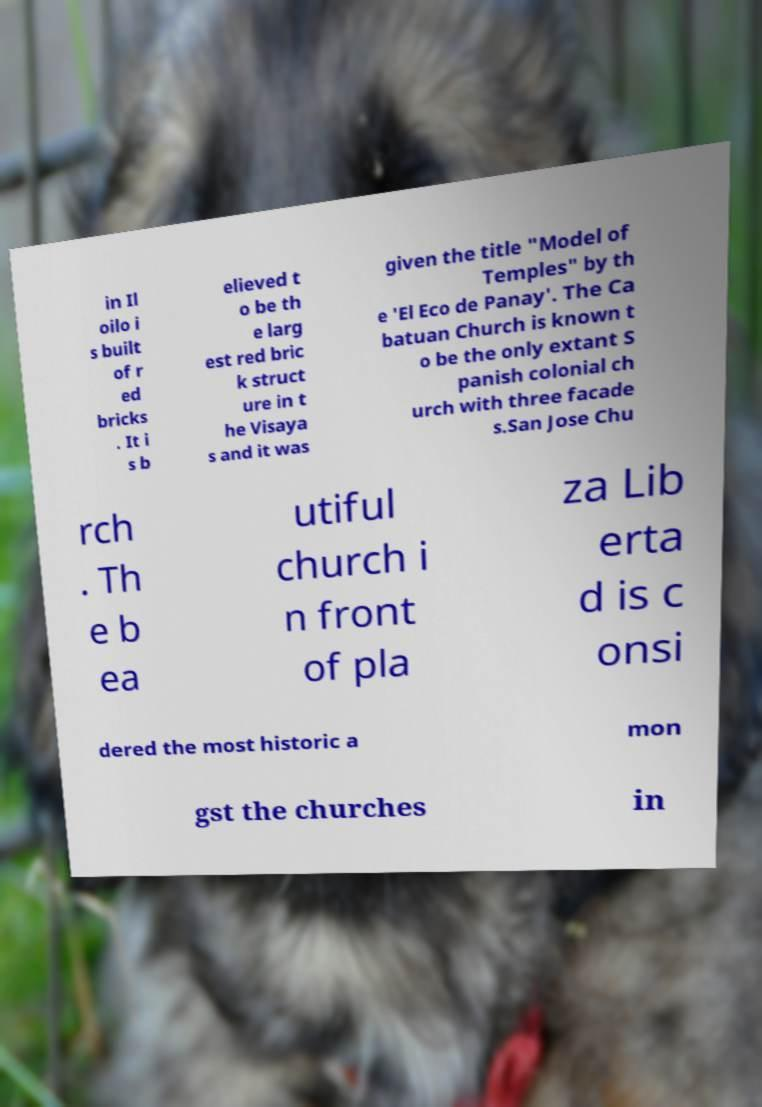For documentation purposes, I need the text within this image transcribed. Could you provide that? in Il oilo i s built of r ed bricks . It i s b elieved t o be th e larg est red bric k struct ure in t he Visaya s and it was given the title "Model of Temples" by th e 'El Eco de Panay'. The Ca batuan Church is known t o be the only extant S panish colonial ch urch with three facade s.San Jose Chu rch . Th e b ea utiful church i n front of pla za Lib erta d is c onsi dered the most historic a mon gst the churches in 